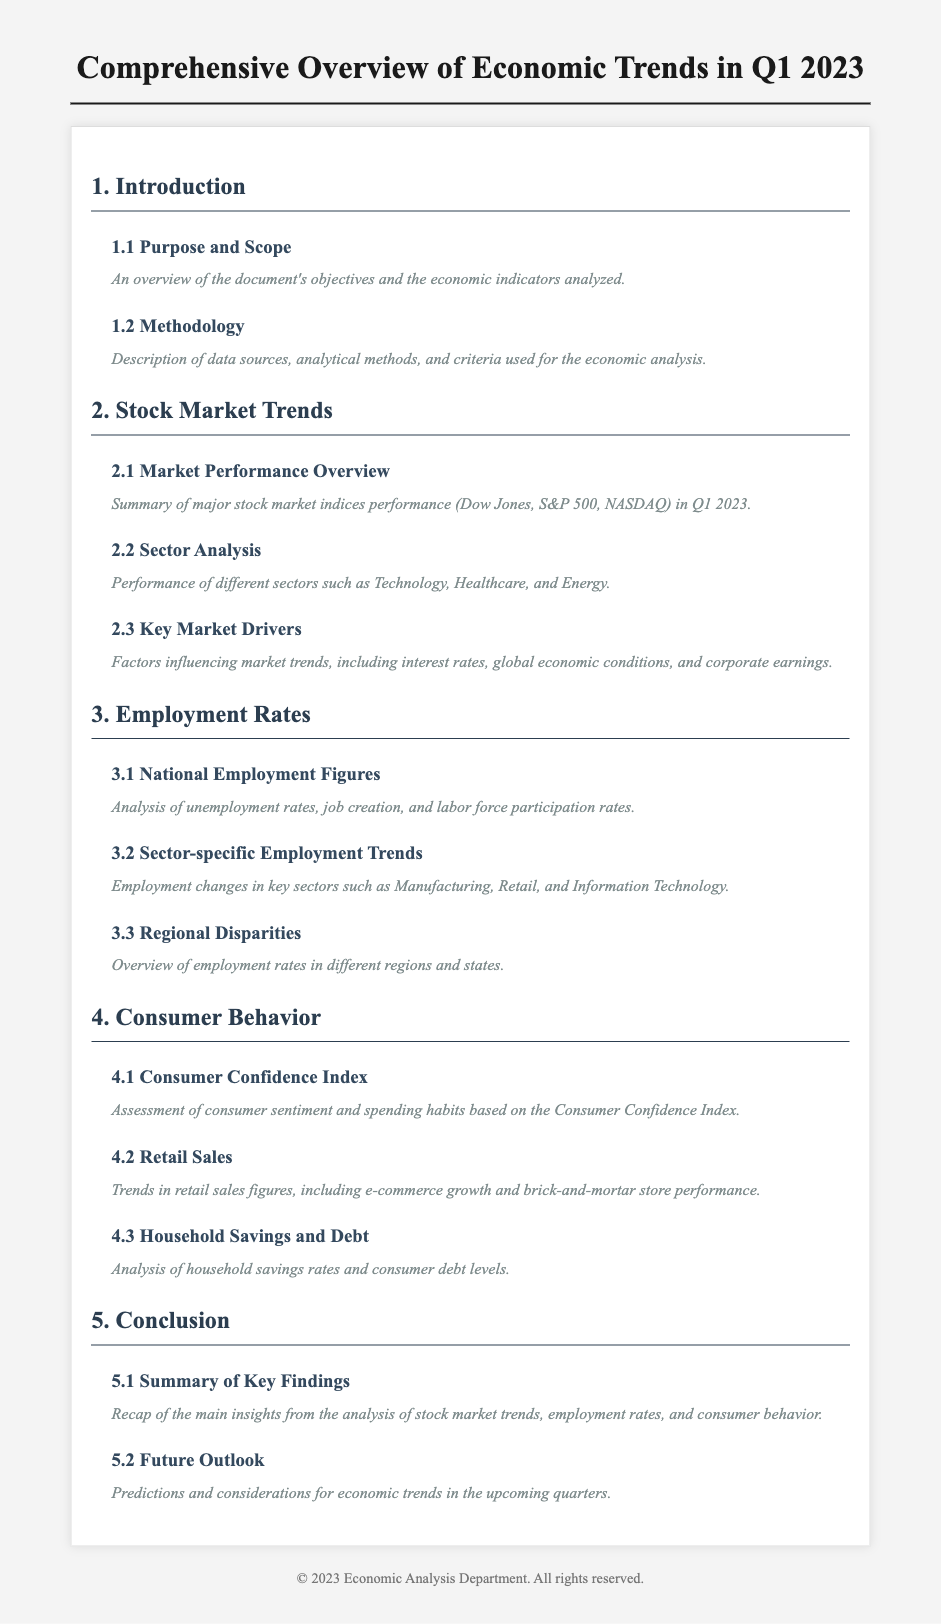What is the purpose of the document? The purpose of the document is to provide an overview of the document's objectives and the economic indicators analyzed.
Answer: Overview of economic indicators What major stock market indices are mentioned? The document lists major stock market indices including the Dow Jones, S&P 500, and NASDAQ.
Answer: Dow Jones, S&P 500, NASDAQ What is the focus of Section 3? Section 3 focuses on analyzing employment rates and figures, including unemployment rates and job creation.
Answer: Employment rates What does the Consumer Behavior section assess? The Consumer Behavior section assesses consumer sentiment and spending habits based on the Consumer Confidence Index.
Answer: Consumer sentiment What is summarized in the Conclusion section? The Conclusion section provides a recap of the main insights from the analysis of stock market trends, employment rates, and consumer behavior.
Answer: Main insights recap Which sector's employment trends are analyzed? The document mentions analyzing employment trends in the Manufacturing, Retail, and Information Technology sectors.
Answer: Manufacturing, Retail, Information Technology How many subsections are in the Stock Market Trends section? The Stock Market Trends section has three subsections: Market Performance Overview, Sector Analysis, and Key Market Drivers.
Answer: Three subsections What does the future outlook predict? The future outlook predicts considerations for economic trends in the upcoming quarters.
Answer: Economic trends predictions 